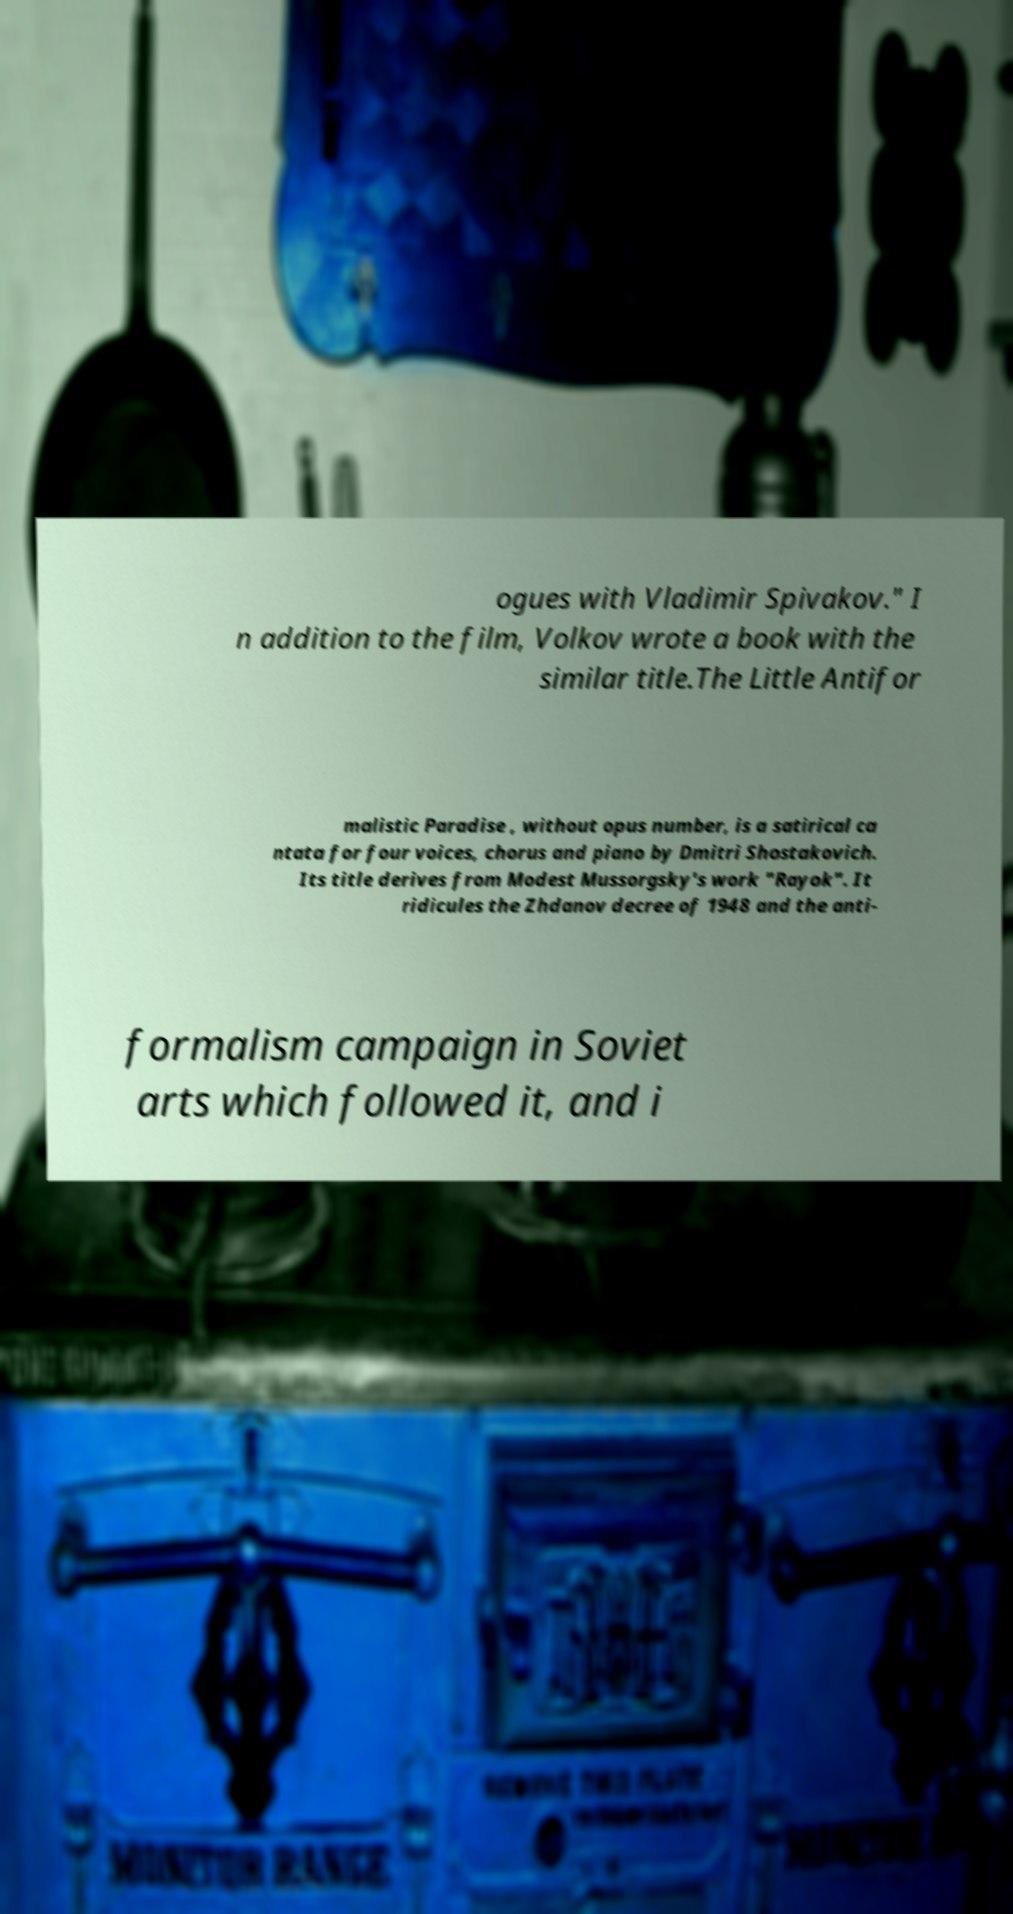For documentation purposes, I need the text within this image transcribed. Could you provide that? ogues with Vladimir Spivakov." I n addition to the film, Volkov wrote a book with the similar title.The Little Antifor malistic Paradise , without opus number, is a satirical ca ntata for four voices, chorus and piano by Dmitri Shostakovich. Its title derives from Modest Mussorgsky's work "Rayok". It ridicules the Zhdanov decree of 1948 and the anti- formalism campaign in Soviet arts which followed it, and i 